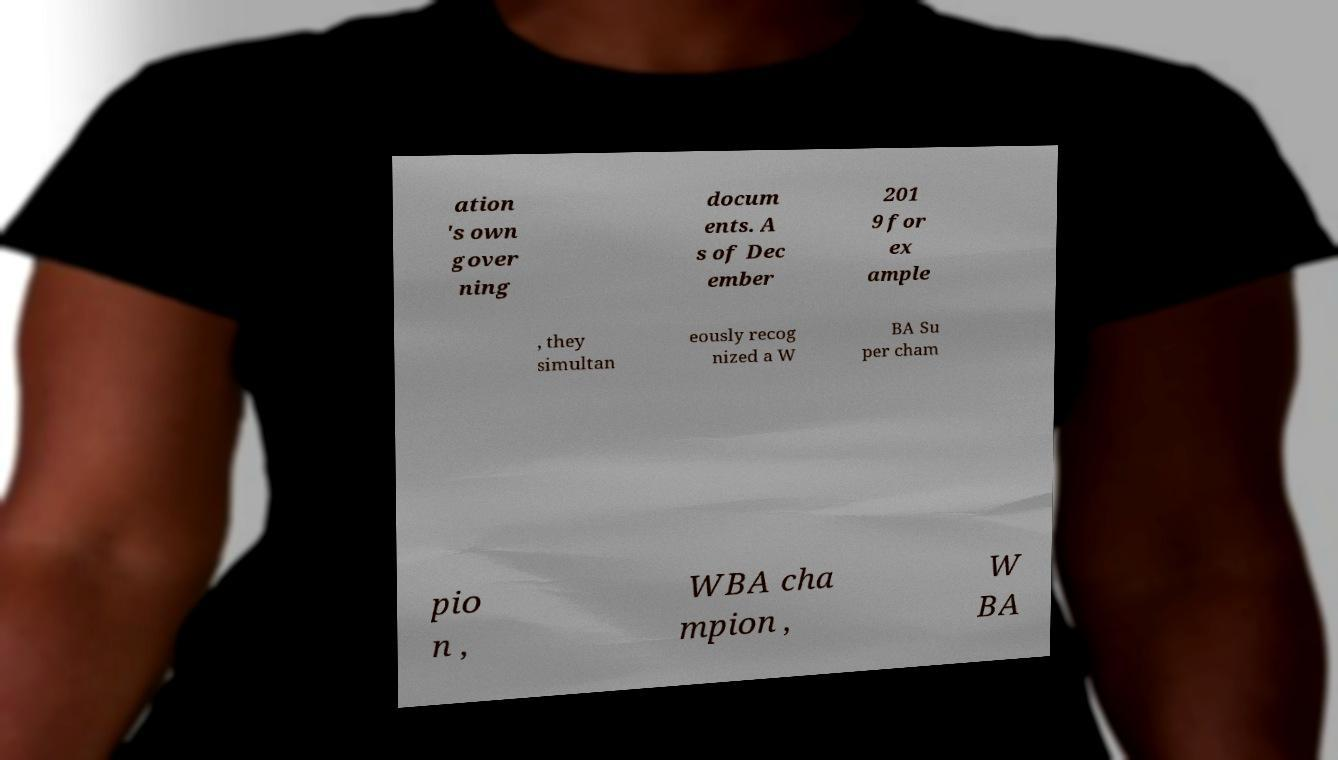Please identify and transcribe the text found in this image. ation 's own gover ning docum ents. A s of Dec ember 201 9 for ex ample , they simultan eously recog nized a W BA Su per cham pio n , WBA cha mpion , W BA 